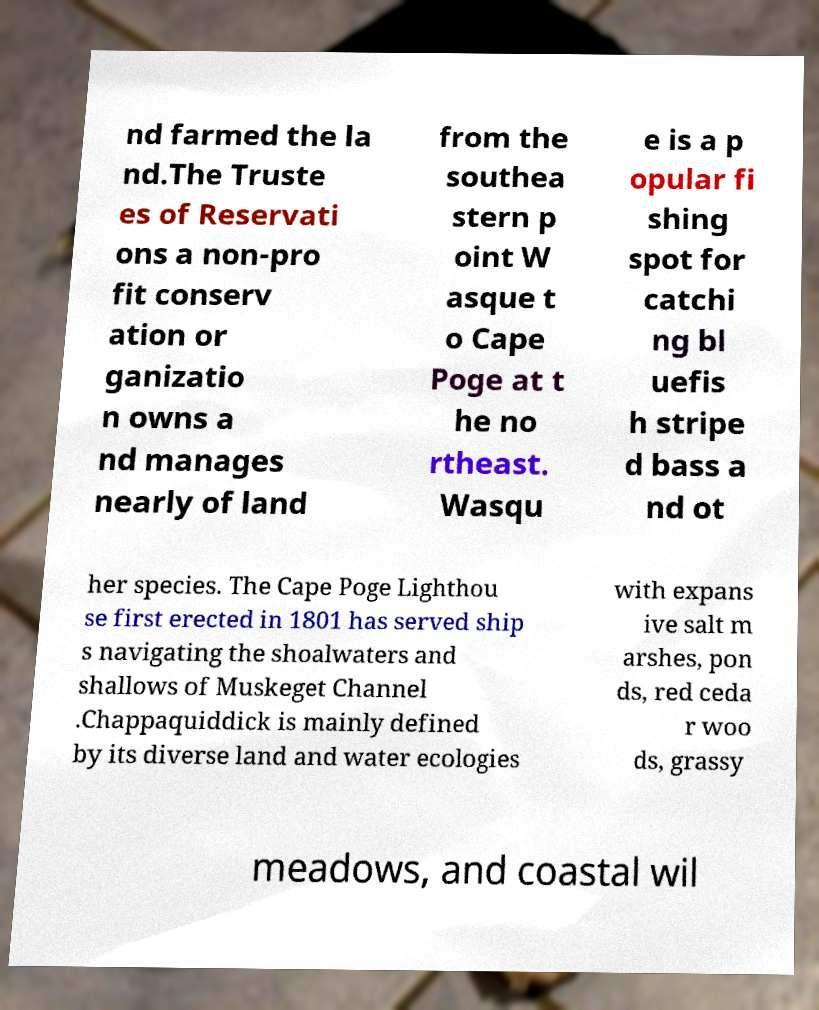For documentation purposes, I need the text within this image transcribed. Could you provide that? nd farmed the la nd.The Truste es of Reservati ons a non-pro fit conserv ation or ganizatio n owns a nd manages nearly of land from the southea stern p oint W asque t o Cape Poge at t he no rtheast. Wasqu e is a p opular fi shing spot for catchi ng bl uefis h stripe d bass a nd ot her species. The Cape Poge Lighthou se first erected in 1801 has served ship s navigating the shoalwaters and shallows of Muskeget Channel .Chappaquiddick is mainly defined by its diverse land and water ecologies with expans ive salt m arshes, pon ds, red ceda r woo ds, grassy meadows, and coastal wil 